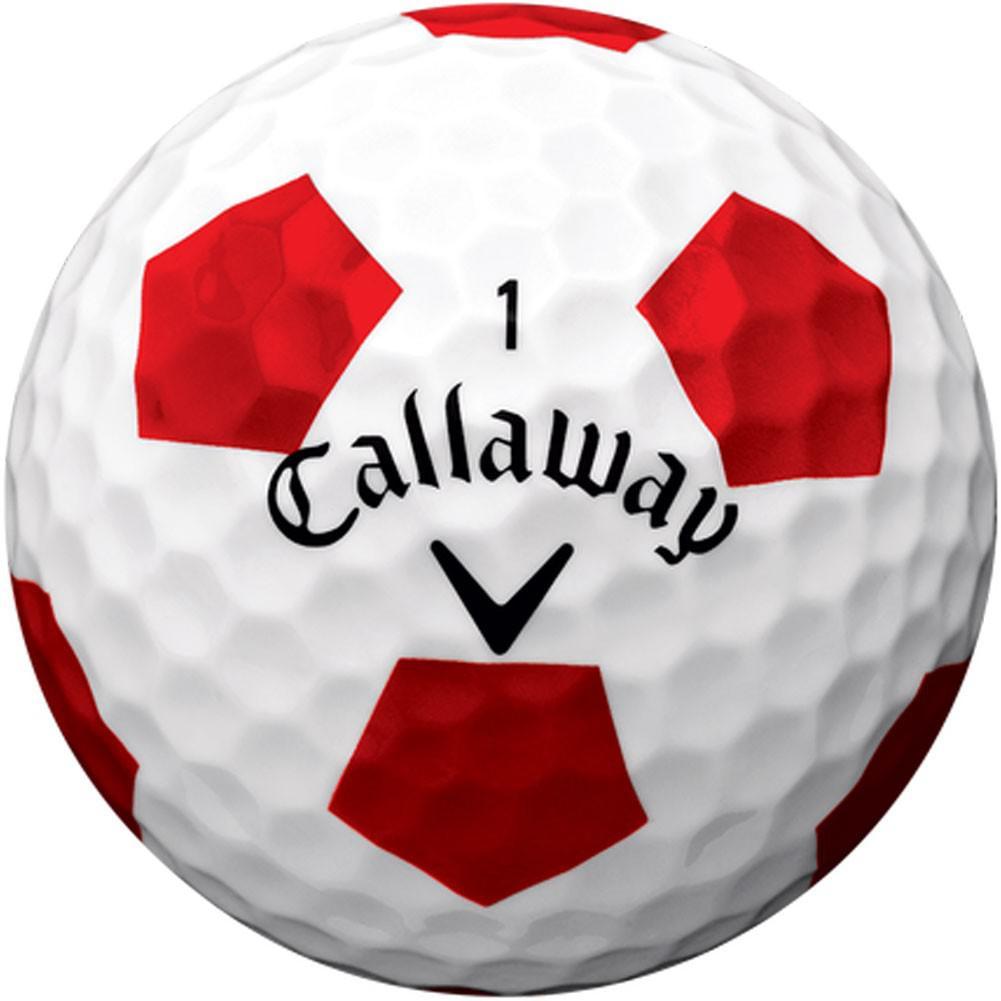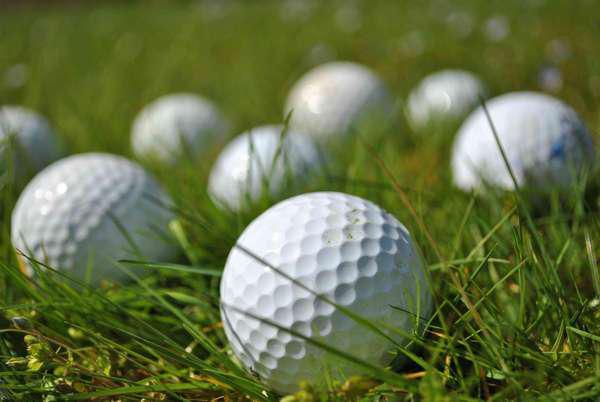The first image is the image on the left, the second image is the image on the right. Considering the images on both sides, is "there are exactly three balls in one of the images." valid? Answer yes or no. No. 